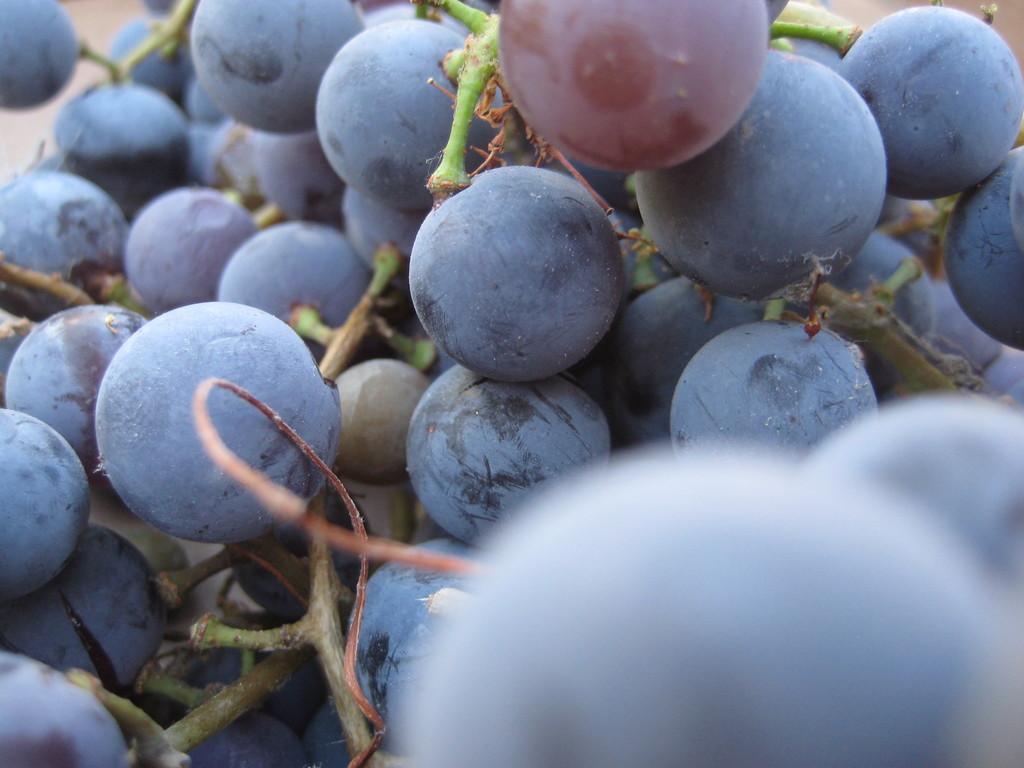Can you describe this image briefly? In this image I can see grapes and the grapes are in black color. 